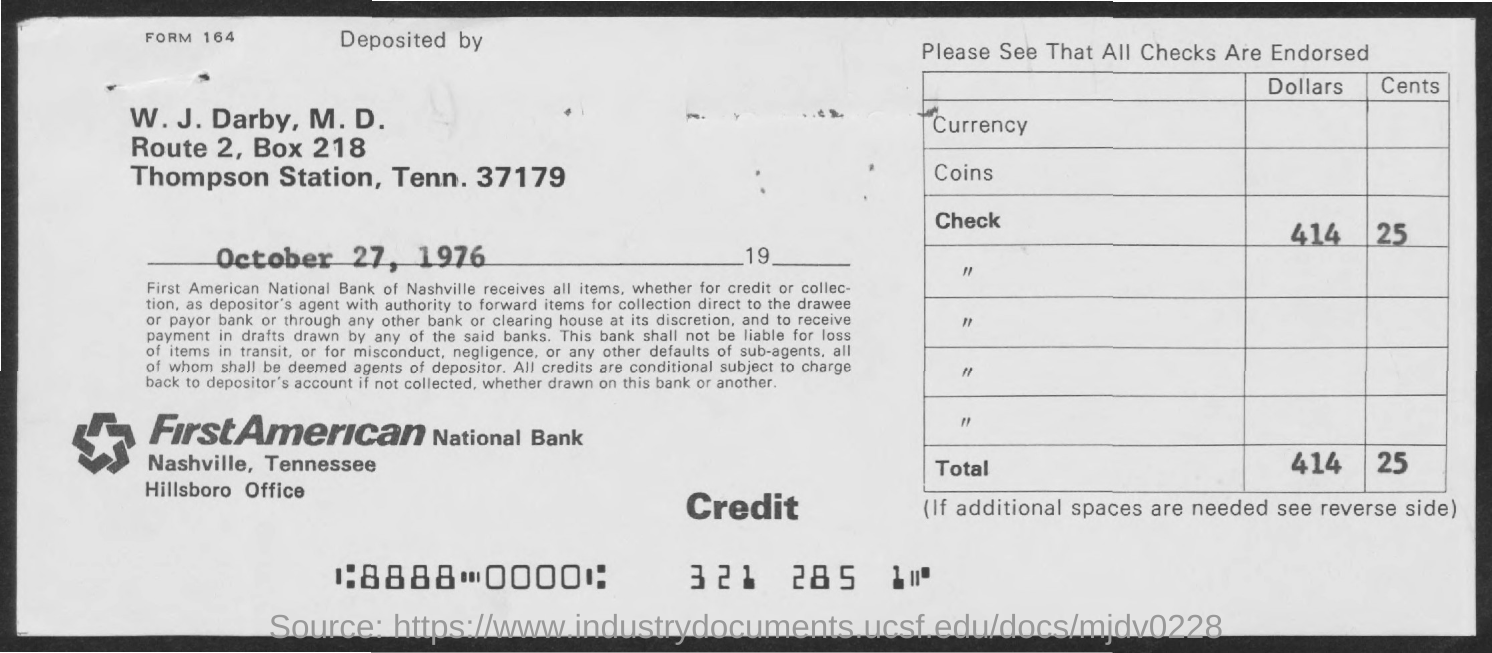Draw attention to some important aspects in this diagram. The BOX number is 218. The Bank Name is FirstAmerican National Bank. The memorandum was dated on October 27, 1976. 